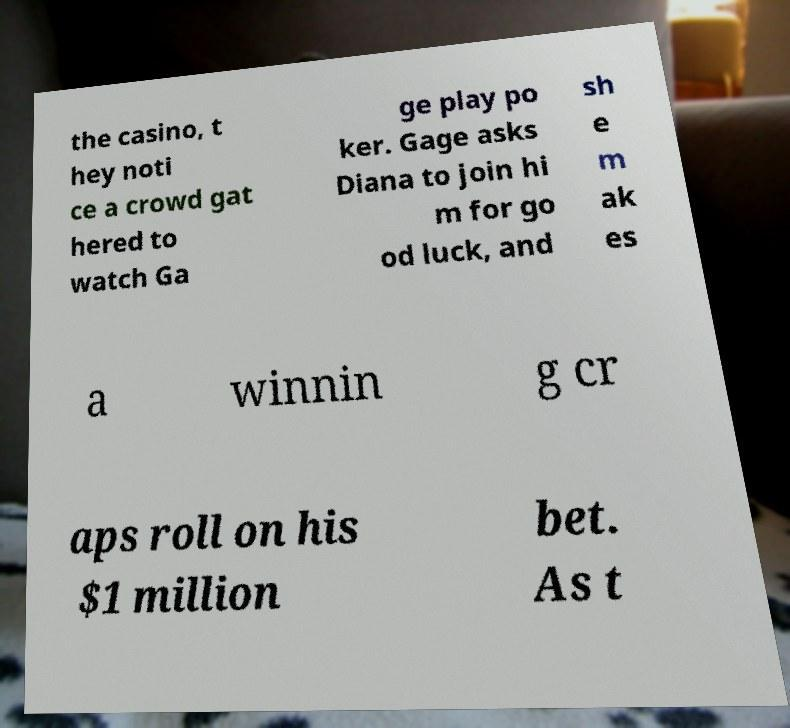There's text embedded in this image that I need extracted. Can you transcribe it verbatim? the casino, t hey noti ce a crowd gat hered to watch Ga ge play po ker. Gage asks Diana to join hi m for go od luck, and sh e m ak es a winnin g cr aps roll on his $1 million bet. As t 